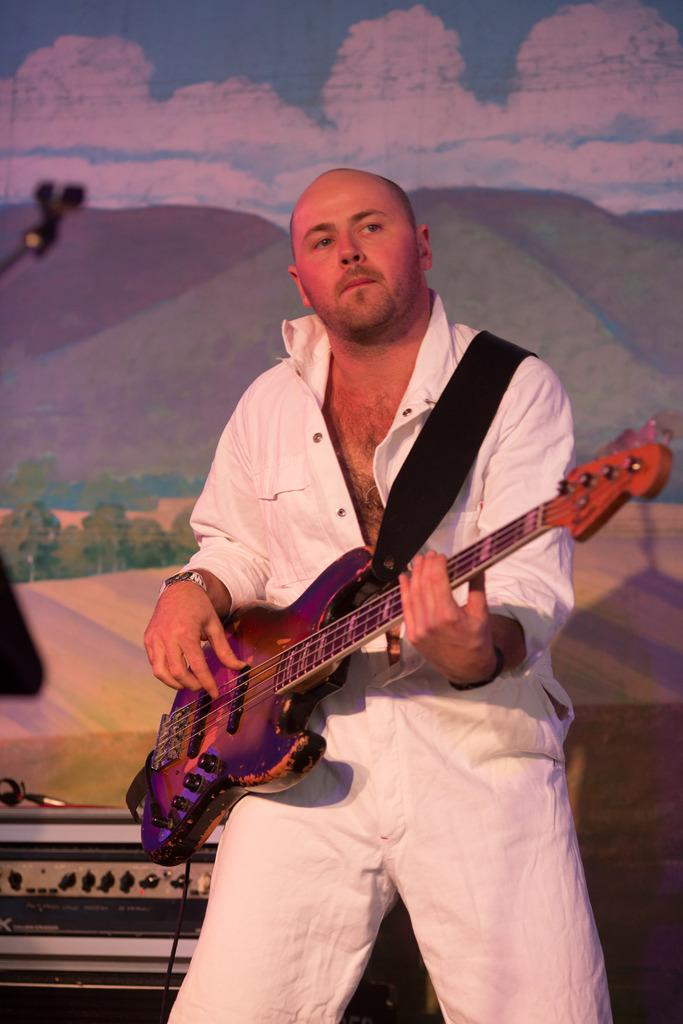Who is present in the image? There is a man in the image. What is the man doing in the image? The man is standing in the image. What object is the man holding in the image? The man is holding a guitar in the image. How many chairs can be seen in the image? There are no chairs present in the image. What type of button is the man wearing on his shirt in the image? The man is not wearing a button on his shirt in the image. 